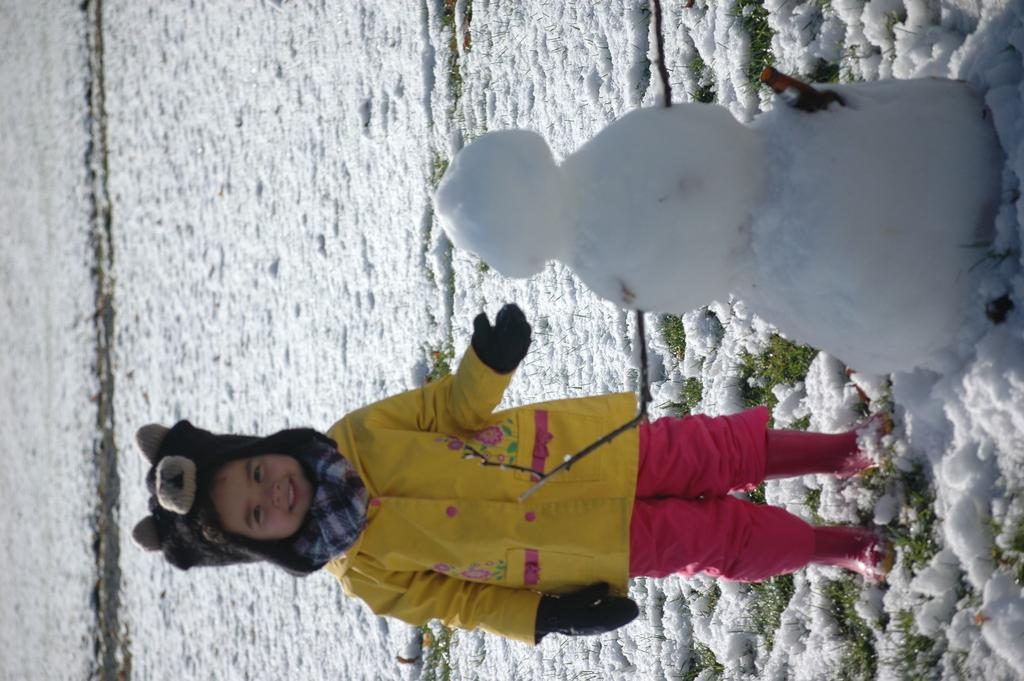What is the main subject of the image? The main subject of the image is a kid standing. What is the kid wearing on their head? The kid is wearing a headgear. What is the kid wearing around their neck? The kid is wearing a scarf. What can be seen on the left side of the image? There is a snowman on the left side of the image. What type of floor is visible in the image? There is both grass and snow on the floor in the image. How many ducks are sitting on the spoon in the image? There are no ducks or spoons present in the image. How many babies are crawling on the grass in the image? There are no babies visible in the image; only a kid standing is present. 